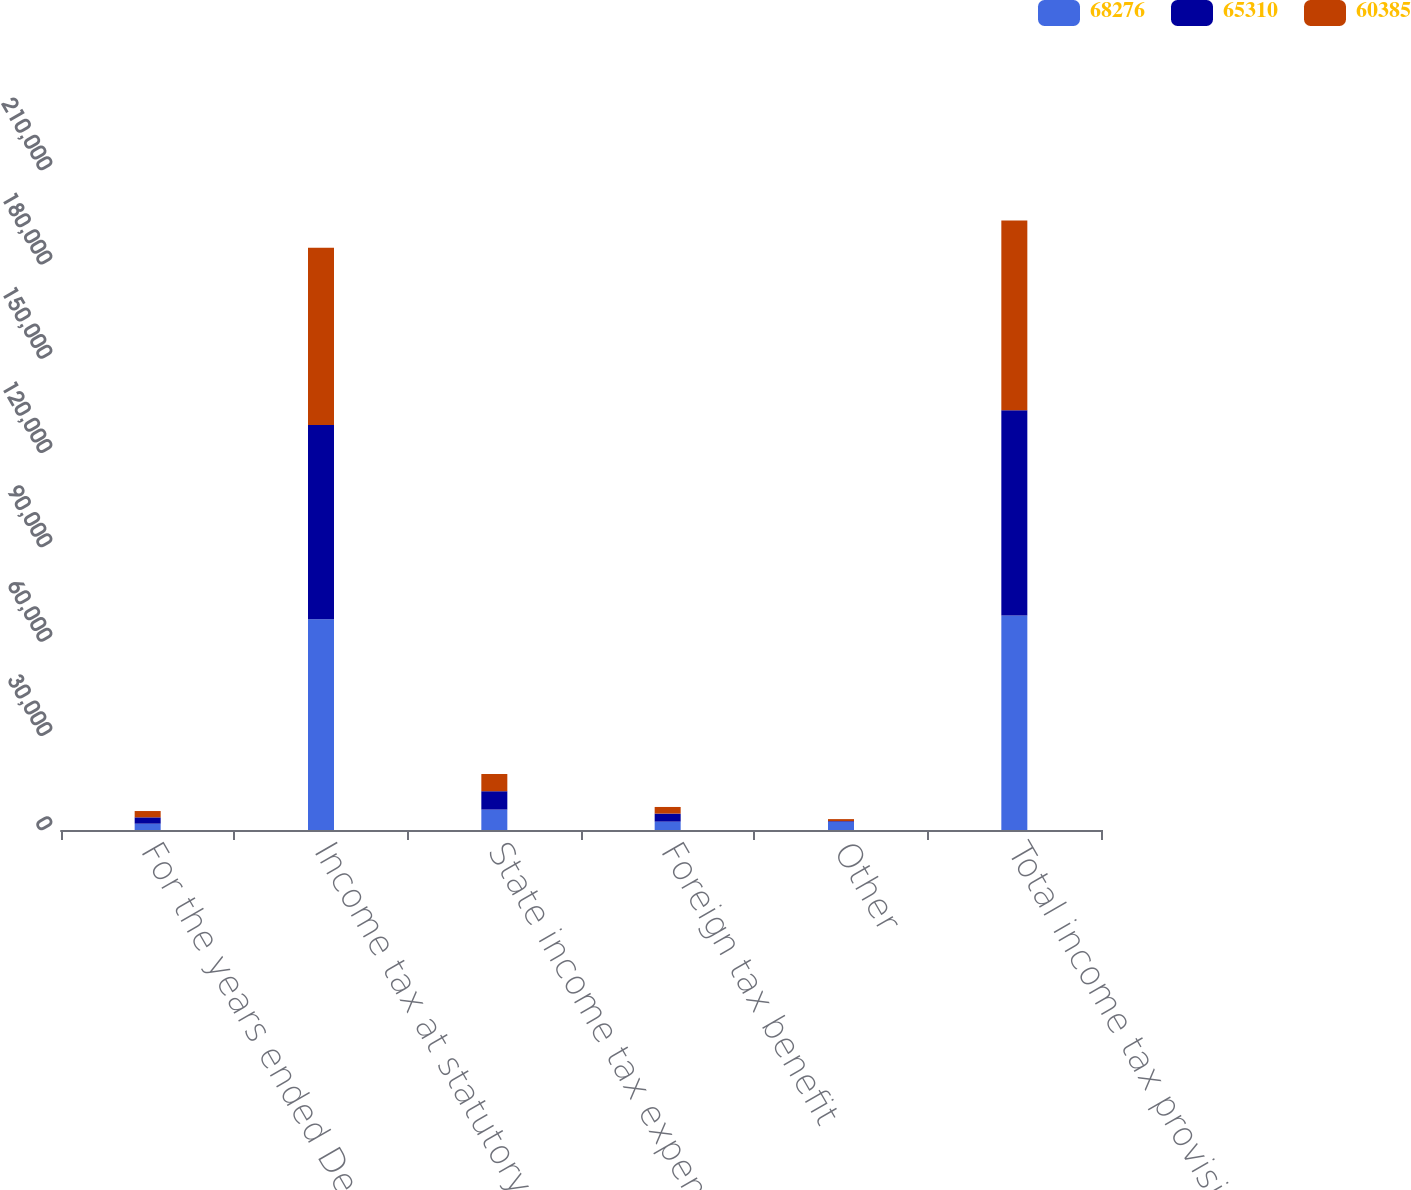<chart> <loc_0><loc_0><loc_500><loc_500><stacked_bar_chart><ecel><fcel>For the years ended December<fcel>Income tax at statutory rate<fcel>State income tax expense (net<fcel>Foreign tax benefit<fcel>Other<fcel>Total income tax provision<nl><fcel>68276<fcel>2013<fcel>67063<fcel>6498<fcel>2661<fcel>2624<fcel>68276<nl><fcel>65310<fcel>2012<fcel>61825<fcel>5835<fcel>2560<fcel>210<fcel>65310<nl><fcel>60385<fcel>2011<fcel>56384<fcel>5477<fcel>2109<fcel>633<fcel>60385<nl></chart> 